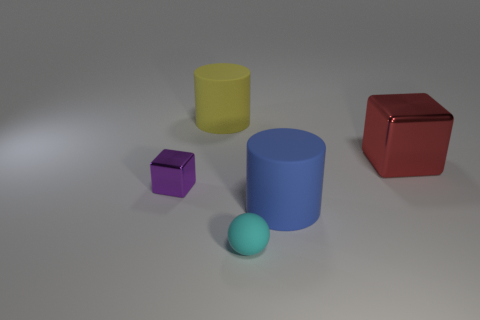What number of cylinders are either large red things or cyan things?
Make the answer very short. 0. Are there more matte balls to the right of the big red shiny thing than large red things that are left of the purple thing?
Keep it short and to the point. No. What is the size of the other cube that is the same material as the tiny block?
Your response must be concise. Large. What number of objects are either objects behind the red object or cylinders?
Ensure brevity in your answer.  2. Do the metal thing on the right side of the small cyan matte thing and the small rubber sphere have the same color?
Your response must be concise. No. The other object that is the same shape as the purple shiny thing is what size?
Keep it short and to the point. Large. What color is the big cylinder that is right of the object in front of the big cylinder in front of the small shiny block?
Give a very brief answer. Blue. Are the big red cube and the cyan ball made of the same material?
Provide a short and direct response. No. There is a rubber cylinder that is left of the small sphere that is in front of the large blue matte object; are there any shiny blocks to the right of it?
Give a very brief answer. Yes. Is the color of the small ball the same as the small shiny block?
Keep it short and to the point. No. 